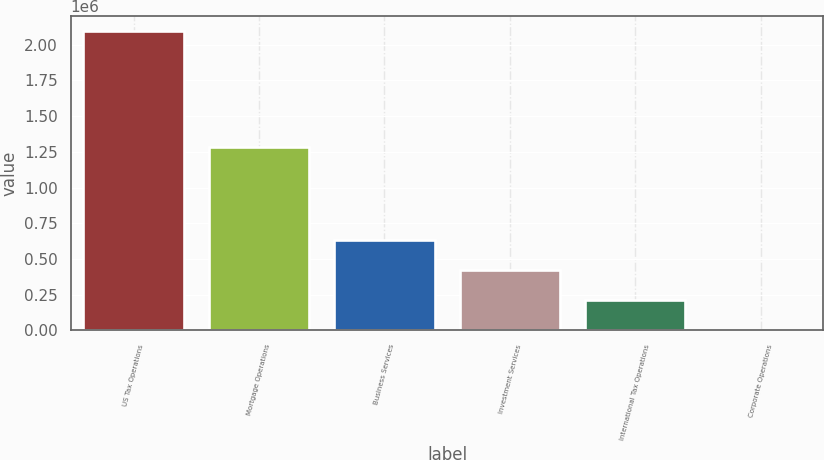Convert chart. <chart><loc_0><loc_0><loc_500><loc_500><bar_chart><fcel>US Tax Operations<fcel>Mortgage Operations<fcel>Business Services<fcel>Investment Services<fcel>International Tax Operations<fcel>Corporate Operations<nl><fcel>2.09362e+06<fcel>1.2814e+06<fcel>631105<fcel>422175<fcel>213244<fcel>4314<nl></chart> 